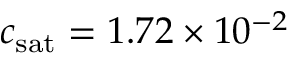<formula> <loc_0><loc_0><loc_500><loc_500>c _ { s a t } = 1 . 7 2 \times 1 0 ^ { - 2 }</formula> 